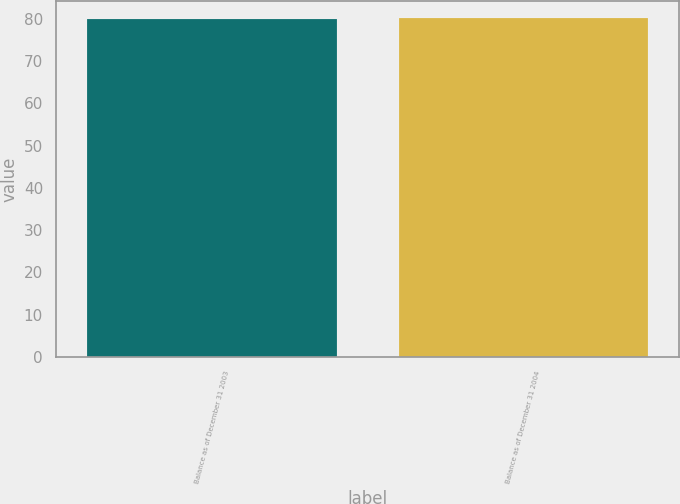<chart> <loc_0><loc_0><loc_500><loc_500><bar_chart><fcel>Balance as of December 31 2003<fcel>Balance as of December 31 2004<nl><fcel>80<fcel>80.1<nl></chart> 